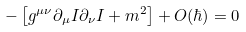<formula> <loc_0><loc_0><loc_500><loc_500>- \left [ g ^ { \mu \nu } \partial _ { \mu } I \partial _ { \nu } I + m ^ { 2 } \right ] + O ( \hbar { ) } = 0</formula> 